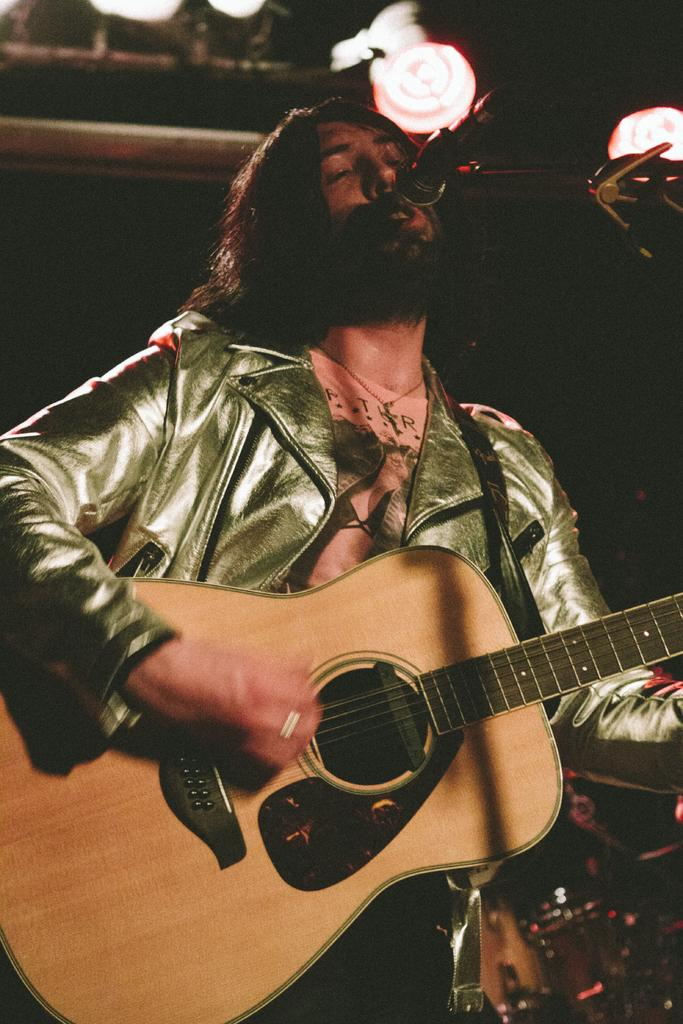What is the main subject of the image? There is a person in the image. What is the person holding in the image? The person is holding a guitar and a microphone in front of him. How many cattle can be seen grazing in the background of the image? There are no cattle present in the image. What type of plot is the person standing on in the image? There is no plot visible in the image; it only shows a person holding a guitar and a microphone. 